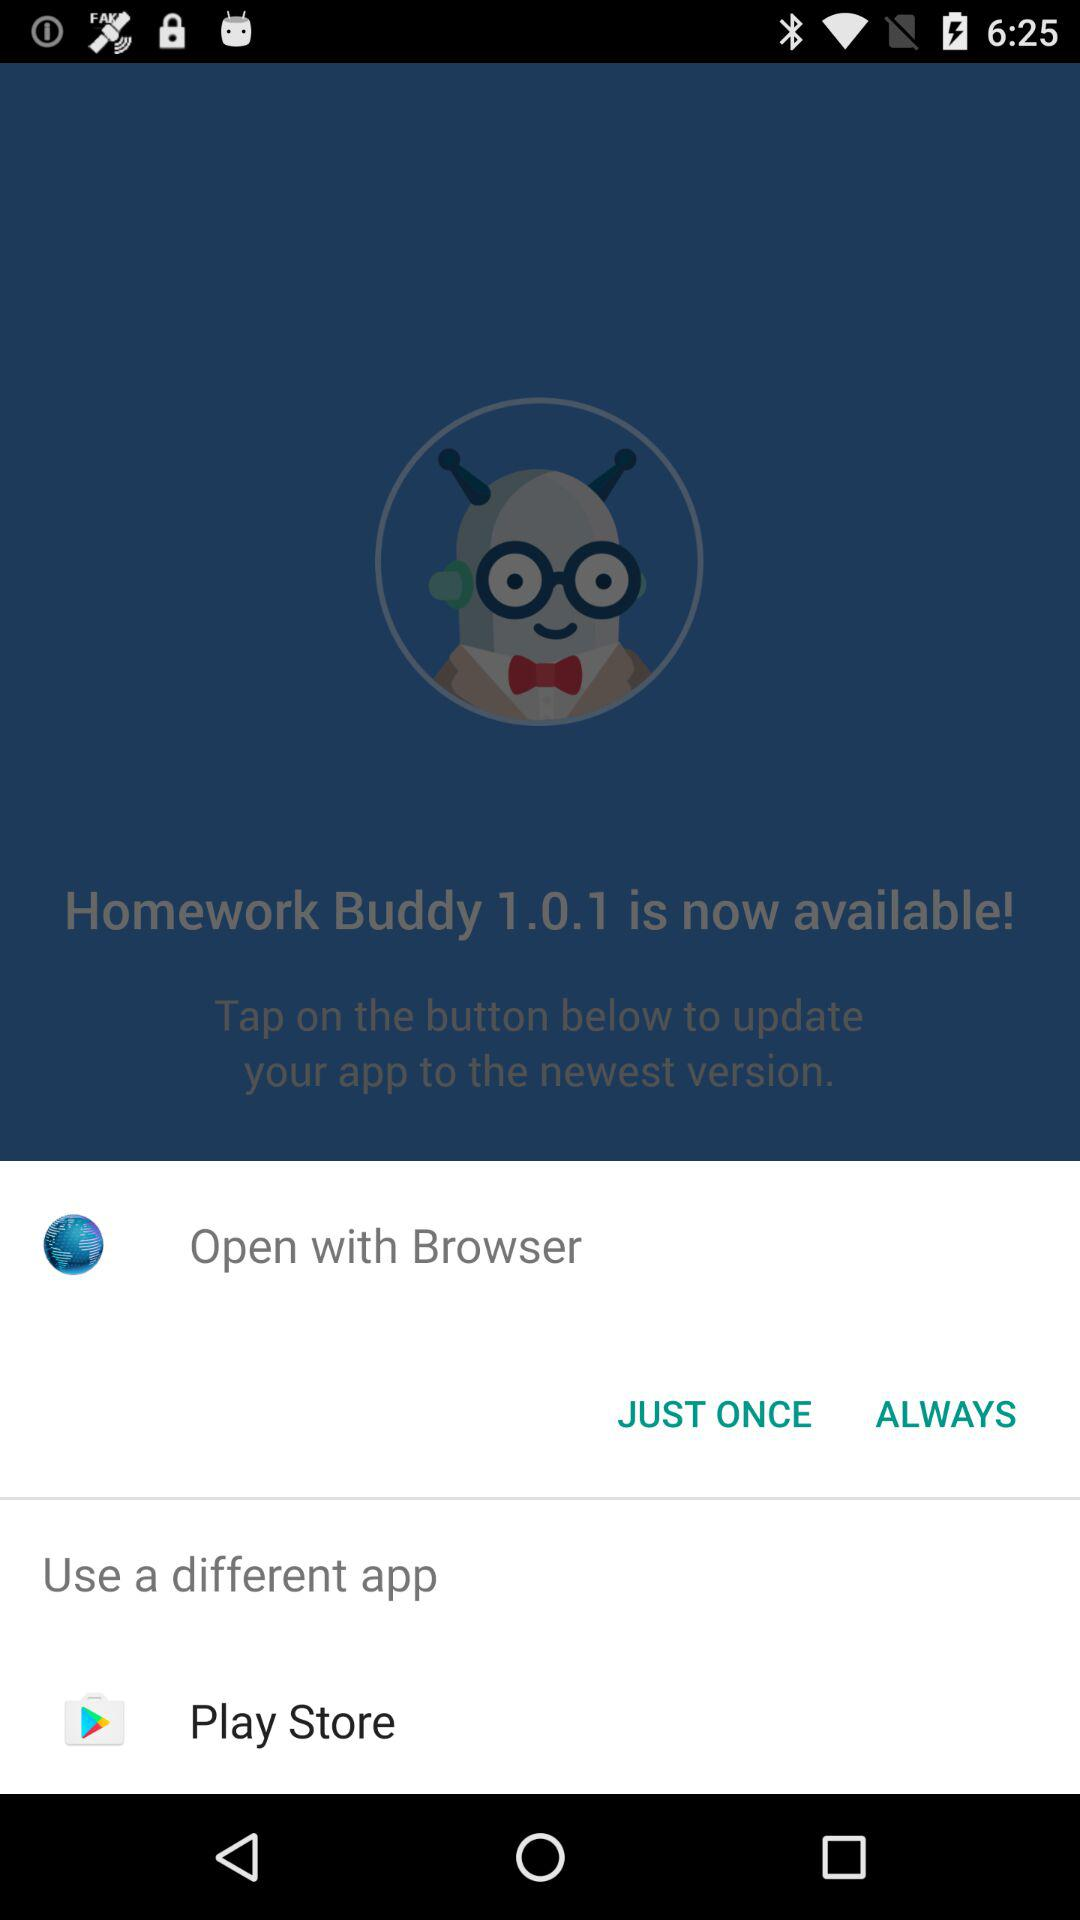Which are the app from which it can be updated?
When the provided information is insufficient, respond with <no answer>. <no answer> 